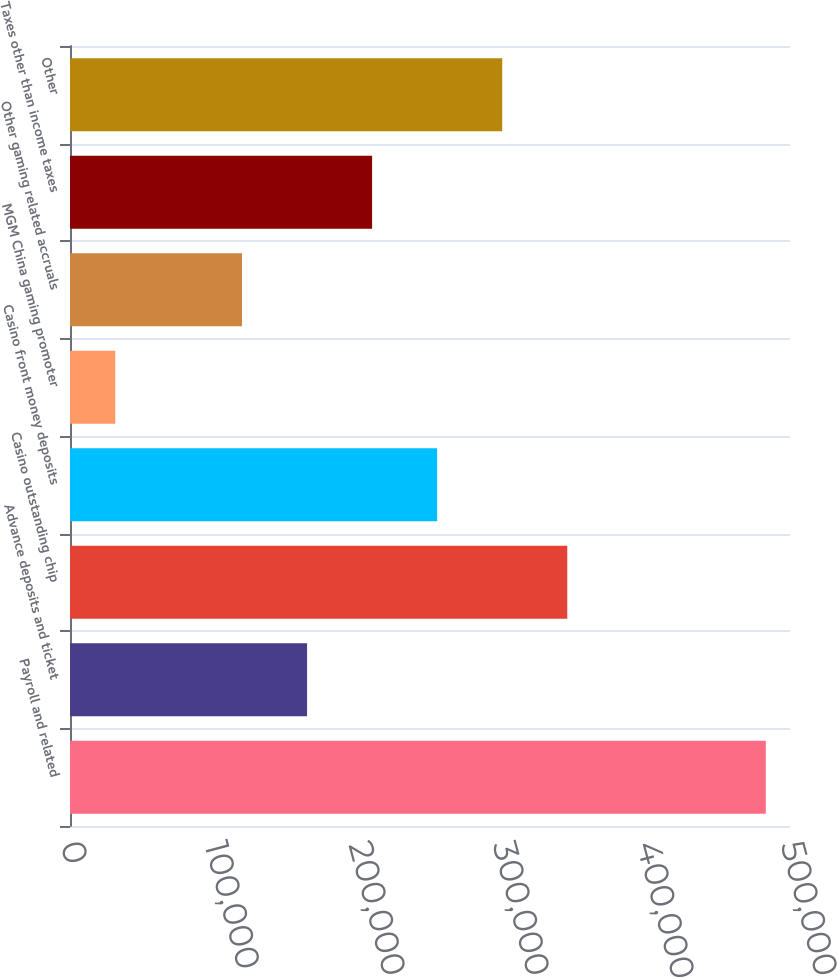Convert chart. <chart><loc_0><loc_0><loc_500><loc_500><bar_chart><fcel>Payroll and related<fcel>Advance deposits and ticket<fcel>Casino outstanding chip<fcel>Casino front money deposits<fcel>MGM China gaming promoter<fcel>Other gaming related accruals<fcel>Taxes other than income taxes<fcel>Other<nl><fcel>483194<fcel>164621<fcel>345320<fcel>254971<fcel>31445<fcel>119446<fcel>209796<fcel>300146<nl></chart> 